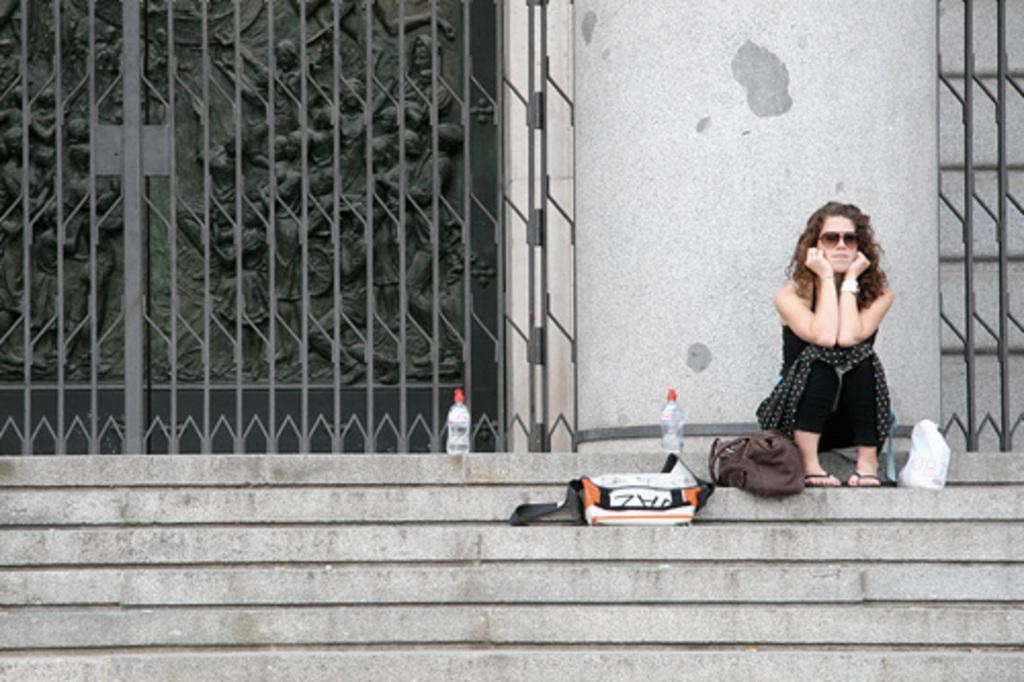Can you describe this image briefly? On the right a woman is sitting on the steps and we can see bottles and bags on the steps. In the background we can see metal gate,wall and sculptures on a platform. 